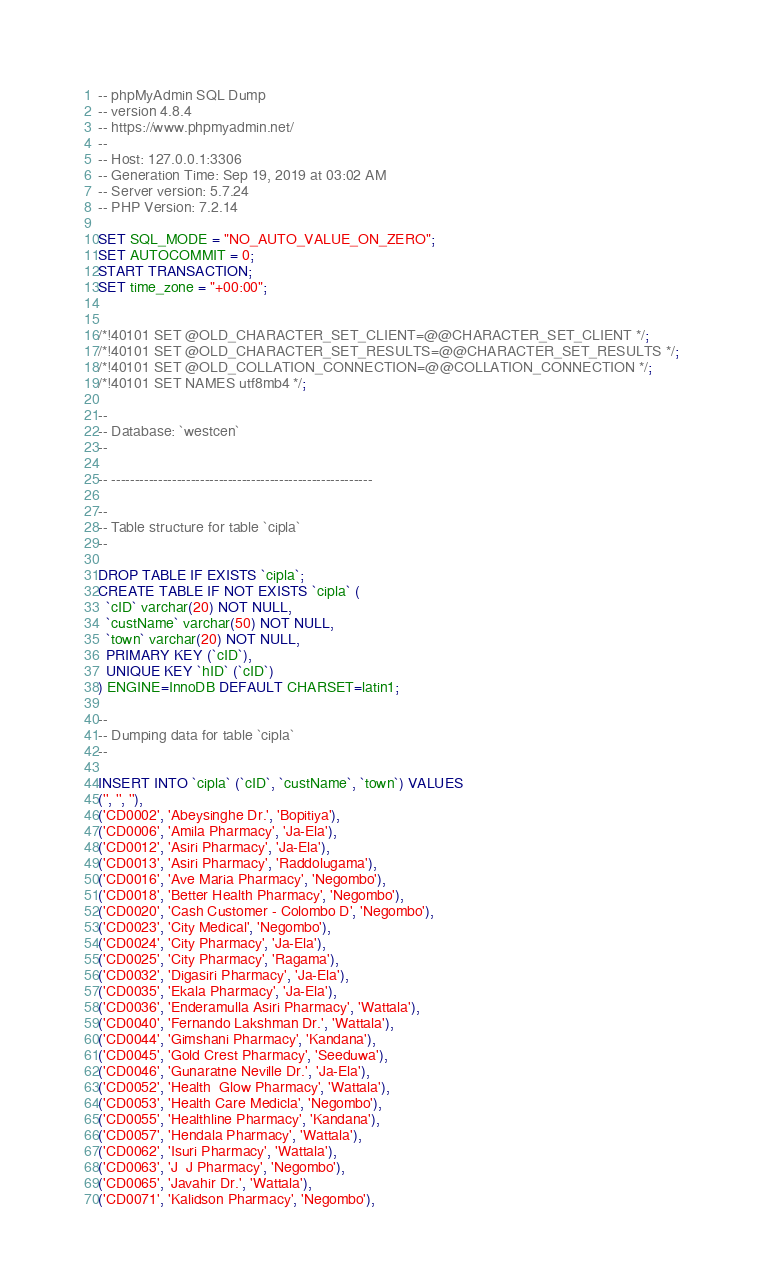<code> <loc_0><loc_0><loc_500><loc_500><_SQL_>-- phpMyAdmin SQL Dump
-- version 4.8.4
-- https://www.phpmyadmin.net/
--
-- Host: 127.0.0.1:3306
-- Generation Time: Sep 19, 2019 at 03:02 AM
-- Server version: 5.7.24
-- PHP Version: 7.2.14

SET SQL_MODE = "NO_AUTO_VALUE_ON_ZERO";
SET AUTOCOMMIT = 0;
START TRANSACTION;
SET time_zone = "+00:00";


/*!40101 SET @OLD_CHARACTER_SET_CLIENT=@@CHARACTER_SET_CLIENT */;
/*!40101 SET @OLD_CHARACTER_SET_RESULTS=@@CHARACTER_SET_RESULTS */;
/*!40101 SET @OLD_COLLATION_CONNECTION=@@COLLATION_CONNECTION */;
/*!40101 SET NAMES utf8mb4 */;

--
-- Database: `westcen`
--

-- --------------------------------------------------------

--
-- Table structure for table `cipla`
--

DROP TABLE IF EXISTS `cipla`;
CREATE TABLE IF NOT EXISTS `cipla` (
  `cID` varchar(20) NOT NULL,
  `custName` varchar(50) NOT NULL,
  `town` varchar(20) NOT NULL,
  PRIMARY KEY (`cID`),
  UNIQUE KEY `hID` (`cID`)
) ENGINE=InnoDB DEFAULT CHARSET=latin1;

--
-- Dumping data for table `cipla`
--

INSERT INTO `cipla` (`cID`, `custName`, `town`) VALUES
('', '', ''),
('CD0002', 'Abeysinghe Dr.', 'Bopitiya'),
('CD0006', 'Amila Pharmacy', 'Ja-Ela'),
('CD0012', 'Asiri Pharmacy', 'Ja-Ela'),
('CD0013', 'Asiri Pharmacy', 'Raddolugama'),
('CD0016', 'Ave Maria Pharmacy', 'Negombo'),
('CD0018', 'Better Health Pharmacy', 'Negombo'),
('CD0020', 'Cash Customer - Colombo D', 'Negombo'),
('CD0023', 'City Medical', 'Negombo'),
('CD0024', 'City Pharmacy', 'Ja-Ela'),
('CD0025', 'City Pharmacy', 'Ragama'),
('CD0032', 'Digasiri Pharmacy', 'Ja-Ela'),
('CD0035', 'Ekala Pharmacy', 'Ja-Ela'),
('CD0036', 'Enderamulla Asiri Pharmacy', 'Wattala'),
('CD0040', 'Fernando Lakshman Dr.', 'Wattala'),
('CD0044', 'Gimshani Pharmacy', 'Kandana'),
('CD0045', 'Gold Crest Pharmacy', 'Seeduwa'),
('CD0046', 'Gunaratne Neville Dr.', 'Ja-Ela'),
('CD0052', 'Health  Glow Pharmacy', 'Wattala'),
('CD0053', 'Health Care Medicla', 'Negombo'),
('CD0055', 'Healthline Pharmacy', 'Kandana'),
('CD0057', 'Hendala Pharmacy', 'Wattala'),
('CD0062', 'Isuri Pharmacy', 'Wattala'),
('CD0063', 'J  J Pharmacy', 'Negombo'),
('CD0065', 'Javahir Dr.', 'Wattala'),
('CD0071', 'Kalidson Pharmacy', 'Negombo'),</code> 